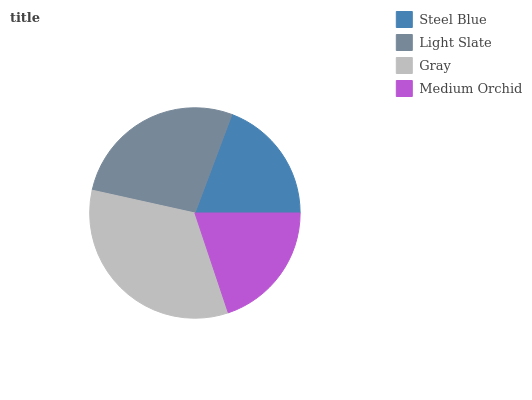Is Steel Blue the minimum?
Answer yes or no. Yes. Is Gray the maximum?
Answer yes or no. Yes. Is Light Slate the minimum?
Answer yes or no. No. Is Light Slate the maximum?
Answer yes or no. No. Is Light Slate greater than Steel Blue?
Answer yes or no. Yes. Is Steel Blue less than Light Slate?
Answer yes or no. Yes. Is Steel Blue greater than Light Slate?
Answer yes or no. No. Is Light Slate less than Steel Blue?
Answer yes or no. No. Is Light Slate the high median?
Answer yes or no. Yes. Is Medium Orchid the low median?
Answer yes or no. Yes. Is Gray the high median?
Answer yes or no. No. Is Gray the low median?
Answer yes or no. No. 